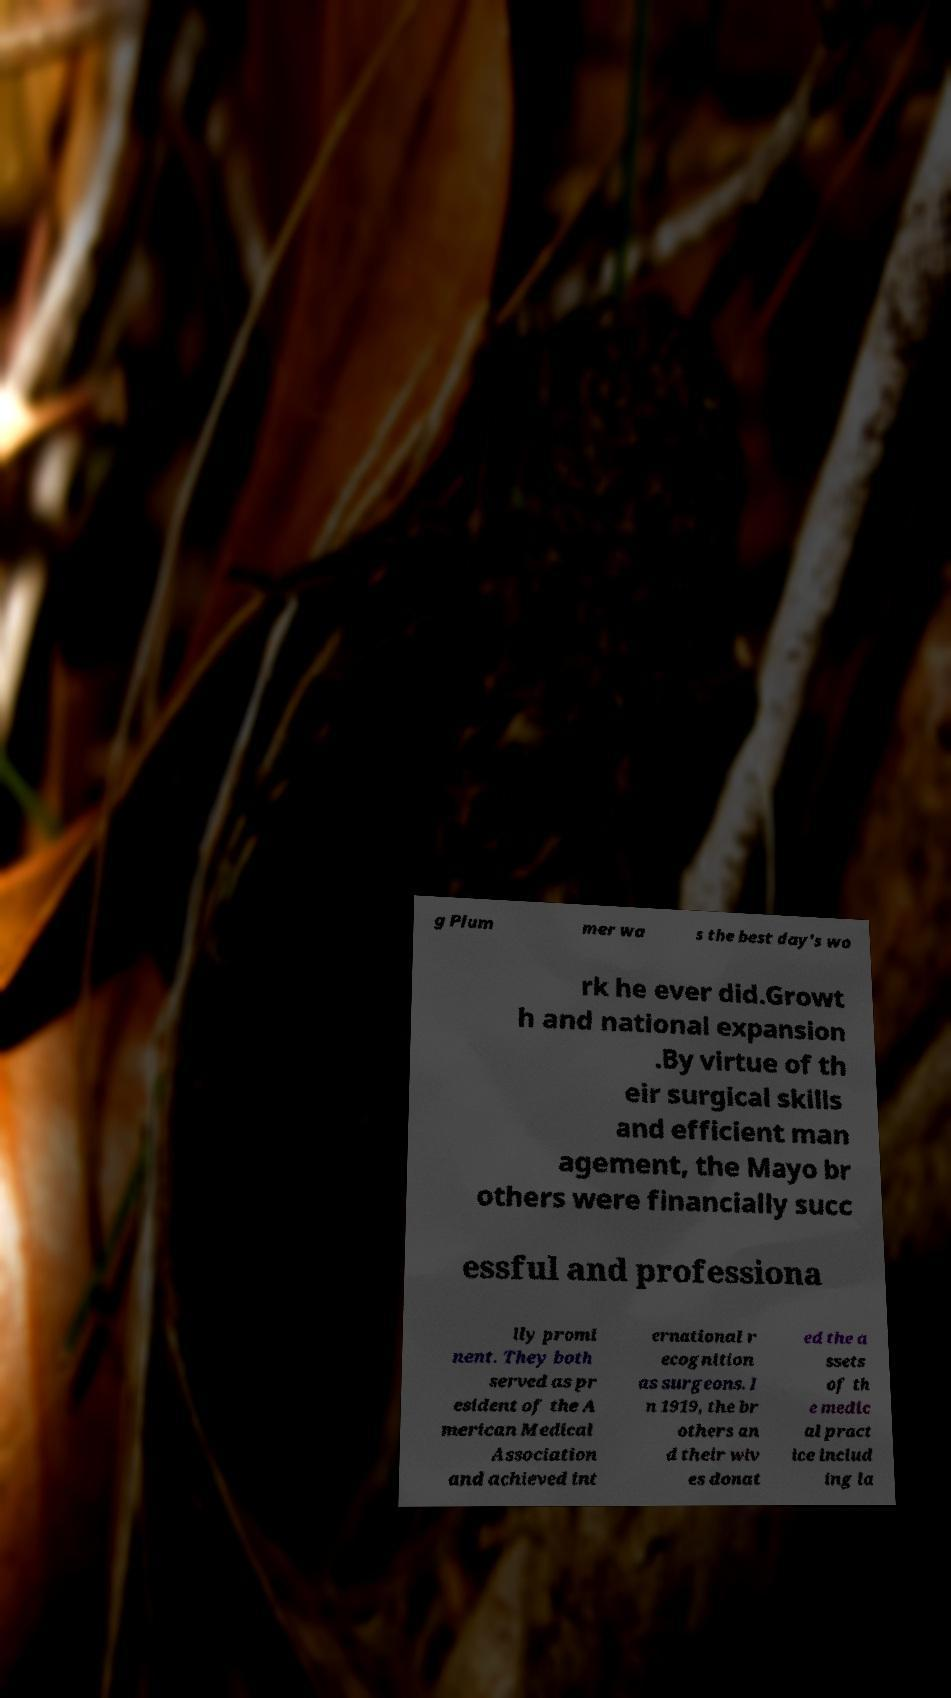What messages or text are displayed in this image? I need them in a readable, typed format. g Plum mer wa s the best day's wo rk he ever did.Growt h and national expansion .By virtue of th eir surgical skills and efficient man agement, the Mayo br others were financially succ essful and professiona lly promi nent. They both served as pr esident of the A merican Medical Association and achieved int ernational r ecognition as surgeons. I n 1919, the br others an d their wiv es donat ed the a ssets of th e medic al pract ice includ ing la 